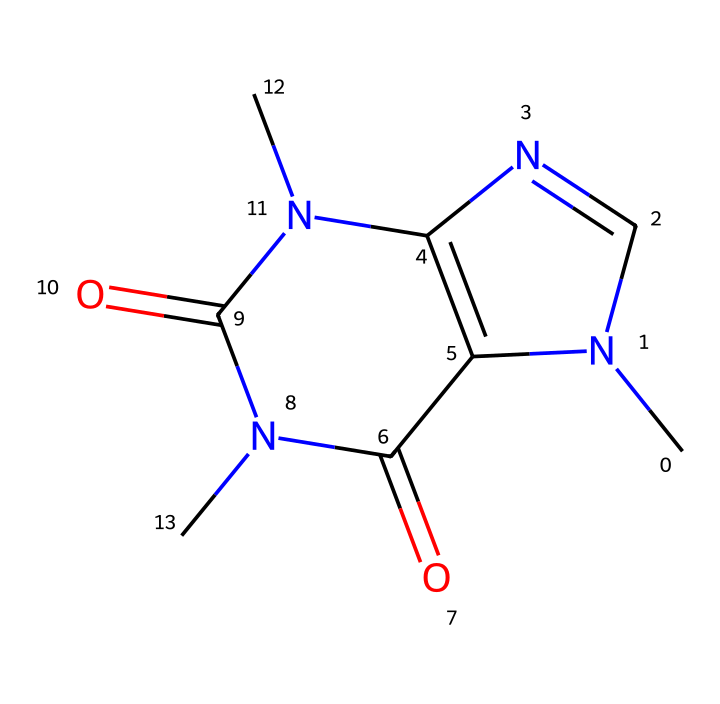What is the molecular formula of caffeine? To determine the molecular formula from the SMILES representation, you can count the number of each type of atom present. The structure CN1C=NC2=C1C(=O)N(C(=O)N2C)C indicates there are five carbons (C), six hydrogens (H), four nitrogens (N), and two oxygens (O). Therefore, the molecular formula is C8H10N4O2.
Answer: C8H10N4O2 How many nitrogen atoms are present in caffeine? In the provided SMILES structure, you can identify the nitrogen atoms by looking for the letter 'N'. There are a total of four 'N' letters in the structure, indicating the presence of four nitrogen atoms.
Answer: 4 What type of drug is caffeine classified as? Caffeine is classified as a stimulant. This classification is derived from its ability to increase alertness and attention, primarily by blocking adenosine receptors in the brain.
Answer: stimulant What is the role of caffeine in cognitive function? Caffeine enhances cognitive function by acting as an adenosine receptor antagonist. This action prevents the drowsiness typically promoted by adenosine, thereby improving alertness, concentration, and overall cognitive performance.
Answer: enhances alertness How many rings are present in the caffeine structure? In the SMILES representation, you can observe the cyclic parts, which are indicated by the numbers indicating the start and end points of the rings. There are two such rings in the caffeine's chemical structure, showcasing its bicyclic nature.
Answer: 2 What is the effect of caffeine on neurotransmitters? Caffeine primarily affects neurotransmitters by increasing the release of catecholamines like dopamine and norepinephrine. This enhancement helps boost mood and focus, contributing to caffeine’s stimulating effects on the brain.
Answer: increases mood 